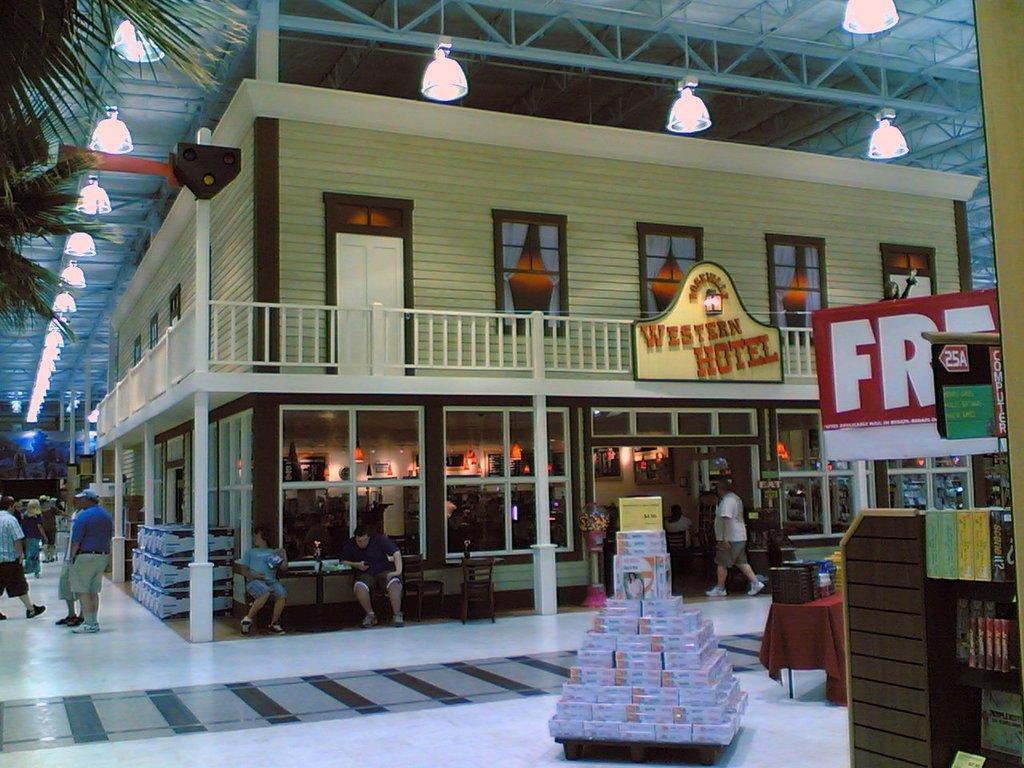Can you describe this image briefly? We can see boxes on the table. On the right side of the image we can see books in racks, boards and objects on the table. There are people. On the left side of the image we can see tree. We can see building, boxes on the floor, chairs, tables, railing, board, pillars and glass windows. At the top we can see lights and rods. 